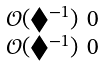Convert formula to latex. <formula><loc_0><loc_0><loc_500><loc_500>\begin{smallmatrix} \mathcal { O } ( \blacklozenge ^ { - 1 } ) & 0 \\ \mathcal { O } ( \blacklozenge ^ { - 1 } ) & 0 \end{smallmatrix}</formula> 